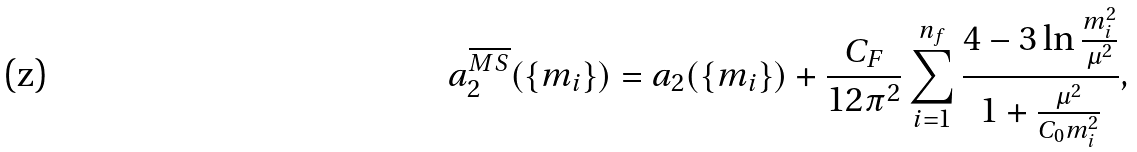Convert formula to latex. <formula><loc_0><loc_0><loc_500><loc_500>a _ { 2 } ^ { \overline { M S } } ( \{ m _ { i } \} ) = a _ { 2 } ( \{ m _ { i } \} ) + \frac { C _ { F } } { 1 2 \pi ^ { 2 } } \sum _ { i = 1 } ^ { n _ { f } } \frac { 4 - 3 \ln \frac { m _ { i } ^ { 2 } } { \mu ^ { 2 } } } { 1 + \frac { \mu ^ { 2 } } { C _ { 0 } m _ { i } ^ { 2 } } } ,</formula> 